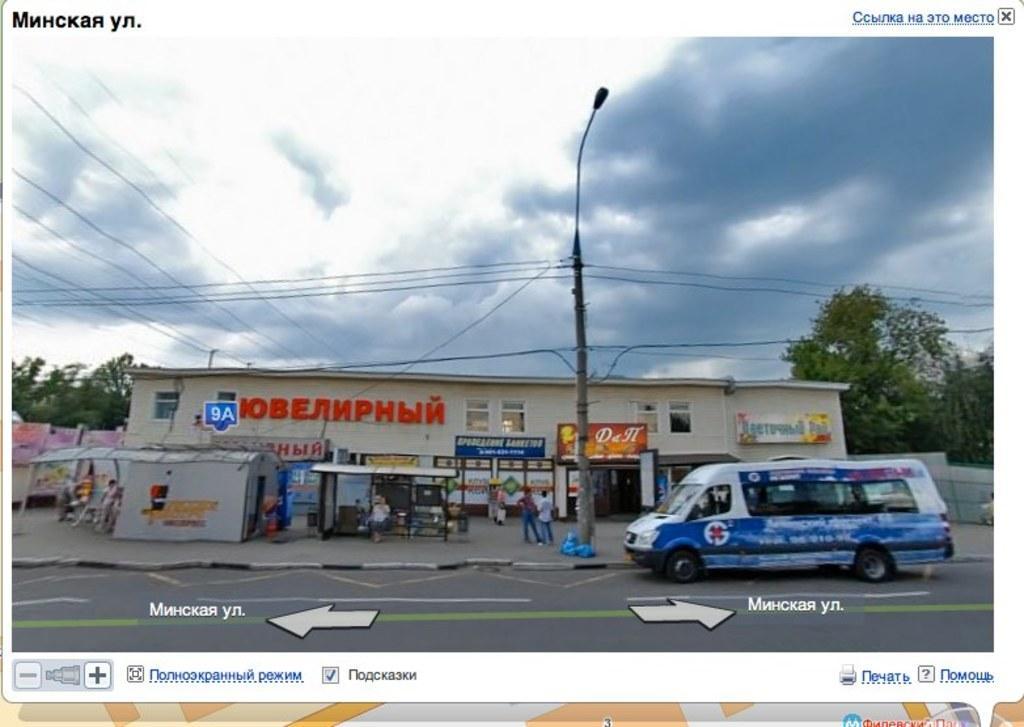Please provide a concise description of this image. This picture seems to be an edited image. On the right there is a van seems to be running on the road and we can see a building, boards, street light attached to the pole and the cables and group of persons. In the background there is a sky, trees and other objects. At the bottom there is a text on the image and we can see the arrows on the image. 